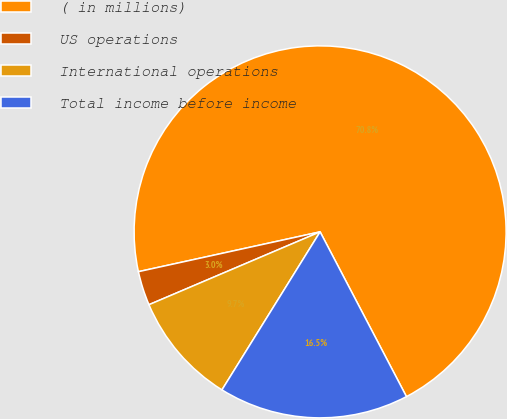Convert chart to OTSL. <chart><loc_0><loc_0><loc_500><loc_500><pie_chart><fcel>( in millions)<fcel>US operations<fcel>International operations<fcel>Total income before income<nl><fcel>70.76%<fcel>2.97%<fcel>9.75%<fcel>16.53%<nl></chart> 